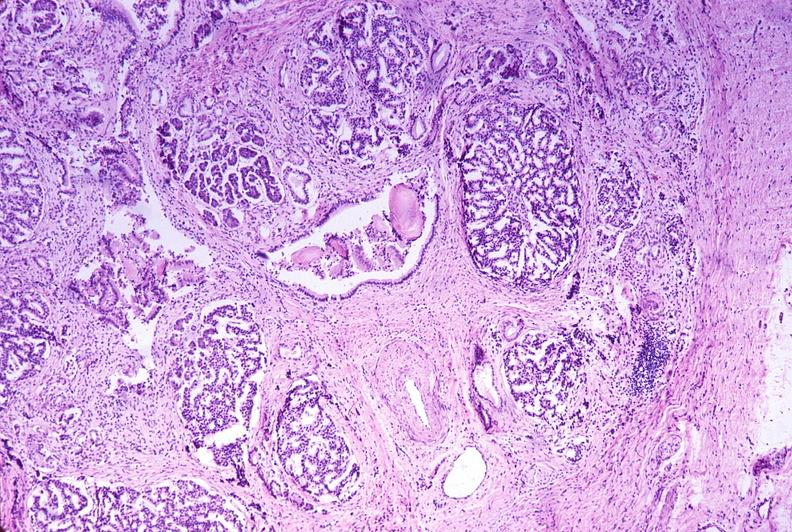does bone, calvarium show chronic pancreatitis?
Answer the question using a single word or phrase. No 